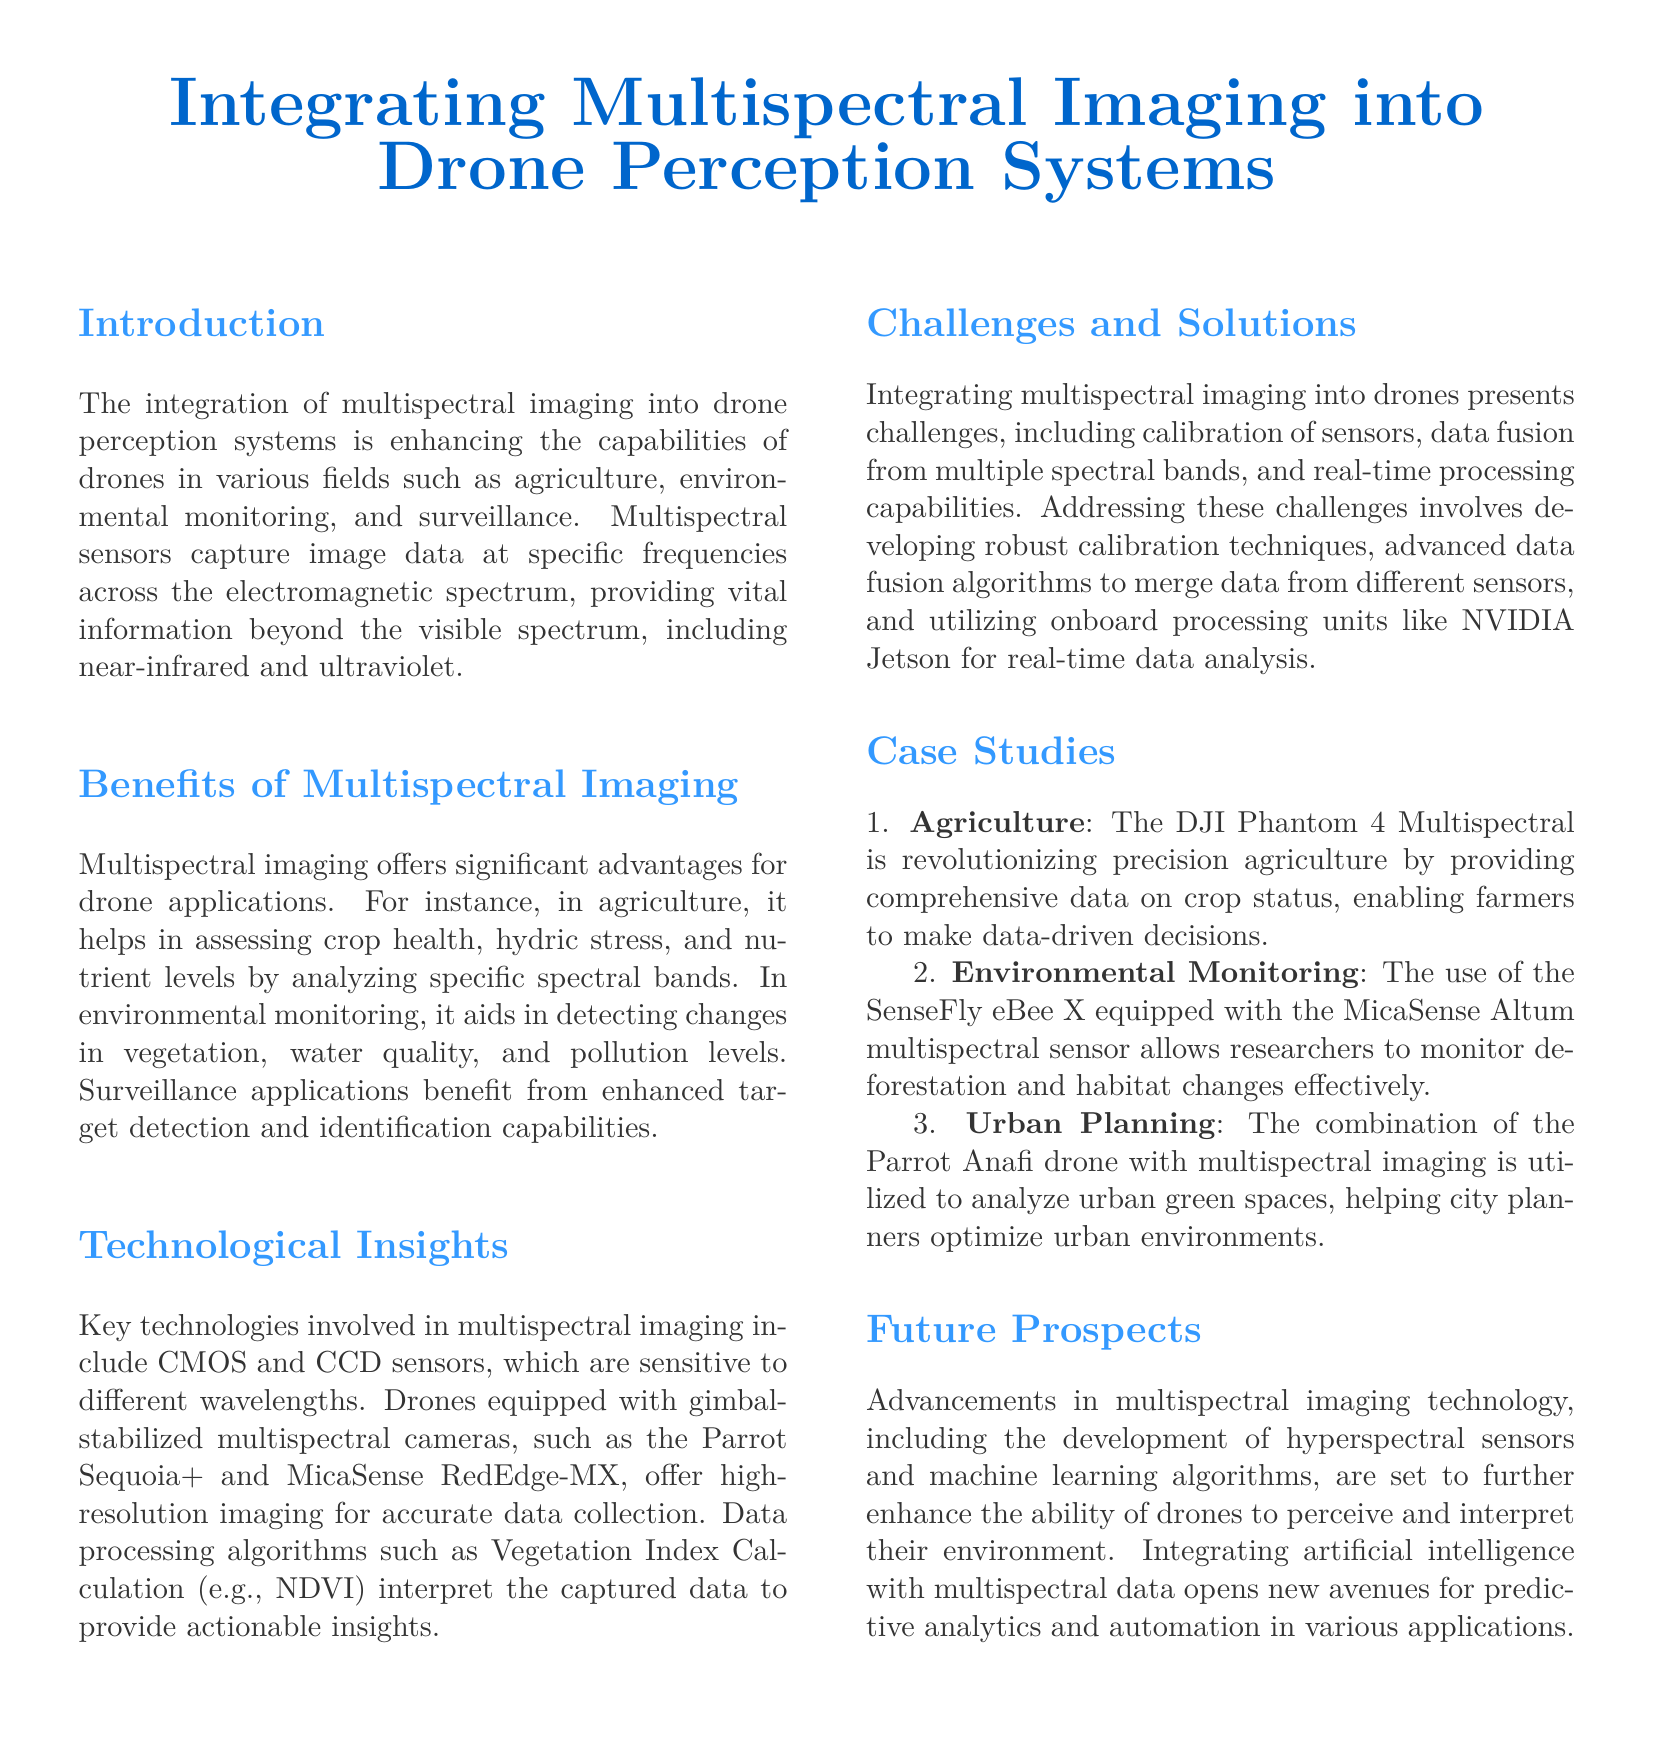what is the title of the document? The title of the document is stated prominently at the beginning and is "Integrating Multispectral Imaging into Drone Perception Systems."
Answer: Integrating Multispectral Imaging into Drone Perception Systems which technology is mentioned as being used in multispectral imaging? The document lists CMOS and CCD sensors as key technologies involved in multispectral imaging.
Answer: CMOS and CCD sensors what specific drone is mentioned for precision agriculture? The DJI Phantom 4 Multispectral is highlighted as a notable drone in the agriculture section.
Answer: DJI Phantom 4 Multispectral what are the benefits of multispectral imaging in environmental monitoring? The document discusses benefits such as detecting changes in vegetation, water quality, and pollution levels.
Answer: Detecting changes in vegetation, water quality, and pollution levels which processing unit is suggested for real-time data analysis? The document recommends utilizing the NVIDIA Jetson for real-time data analysis in multispectral imaging.
Answer: NVIDIA Jetson who is mentioned as the researcher in the environmental monitoring case study? The document does not specify a particular researcher, rather it speaks generally about researchers using the SenseFly eBee X.
Answer: Not specified what does NDVI stand for? NDVI stands for Normalized Difference Vegetation Index, a data processing algorithm mentioned in the document.
Answer: Normalized Difference Vegetation Index how many case studies are presented in the document? The document includes three case studies illustrating applications of multispectral imaging with drones.
Answer: Three what future advancement is anticipated for drone perception systems? The document mentions advancements in hyperspectral sensors as future prospects for enhancing drone perception.
Answer: Hyperspectral sensors 